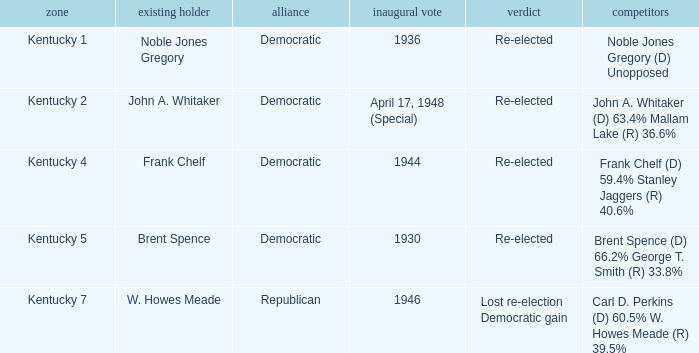What was the result in the voting district Kentucky 2? Re-elected. 